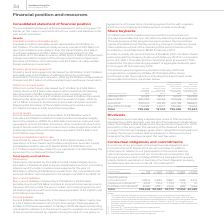According to Vodafone Group Plc's financial document, What information does this table show? summary of our principal contractual financial obligations and commitments at 31 March 2019. The document states: "Contractual obligations and commitments A summary of our principal contractual financial obligations and commitments at 31 March 2019 are set out belo..." Also, What are the total financial liabilities? According to the financial document, 86,160 (in millions). The relevant text states: "years 3–5 years >5 years Financial liabilities 2 86,160 21,953 11,404 14,881 37,922 Operating lease commitments 3 10,816 2,834 2,881 1,689 3,412 Capital co..." Also, What are the total operating lease commitments? According to the financial document, 10,816 (in millions). The relevant text states: "1,404 14,881 37,922 Operating lease commitments 3 10,816 2,834 2,881 1,689 3,412 Capital commitments 3,4 3,012 1,514 1,274 173 51 Purchase commitments 5 8,4..." Additionally, How much financial liabilities are due for payment soonest? According to the financial document, 21,953 (in millions). The relevant text states: "3–5 years >5 years Financial liabilities 2 86,160 21,953 11,404 14,881 37,922 Operating lease commitments 3 10,816 2,834 2,881 1,689 3,412 Capital commitmen..." Also, can you calculate: What percentage of total contractual obligations and commitments is the financial liabilities? Based on the calculation: 86,160/108,448, the result is 79.45 (percentage). This is based on the information: "years 3–5 years >5 years Financial liabilities 2 86,160 21,953 11,404 14,881 37,922 Operating lease commitments 3 10,816 2,834 2,881 1,689 3,412 Capital co e commitments 5 8,460 4,091 2,616 689 1,064 ..." The key data points involved are: 108,448, 86,160. Also, can you calculate: What is the difference between percentage of total capital commitments and total purchase commitments against total contractual obligations and commitments respectively? To answer this question, I need to perform calculations using the financial data. The calculation is: (3,012/108,448) - (8,460/108,448), which equals -5.02 (percentage). This is based on the information: "e commitments 5 8,460 4,091 2,616 689 1,064 Total 108,448 30,392 18,175 17,432 42,449 4 3,012 1,514 1,274 173 51 Purchase commitments 5 8,460 4,091 2,616 689 1,064 Total 108,448 30,392 18,175 17,432 4..." The key data points involved are: 108,448, 3,012, 8,460. 